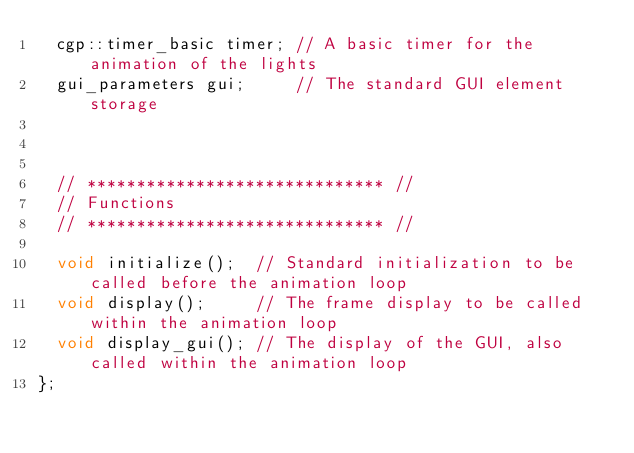Convert code to text. <code><loc_0><loc_0><loc_500><loc_500><_C++_>	cgp::timer_basic timer; // A basic timer for the animation of the lights
	gui_parameters gui;     // The standard GUI element storage
	

	
	// ****************************** //
	// Functions
	// ****************************** //

	void initialize();  // Standard initialization to be called before the animation loop
	void display();     // The frame display to be called within the animation loop
	void display_gui(); // The display of the GUI, also called within the animation loop
};





</code> 